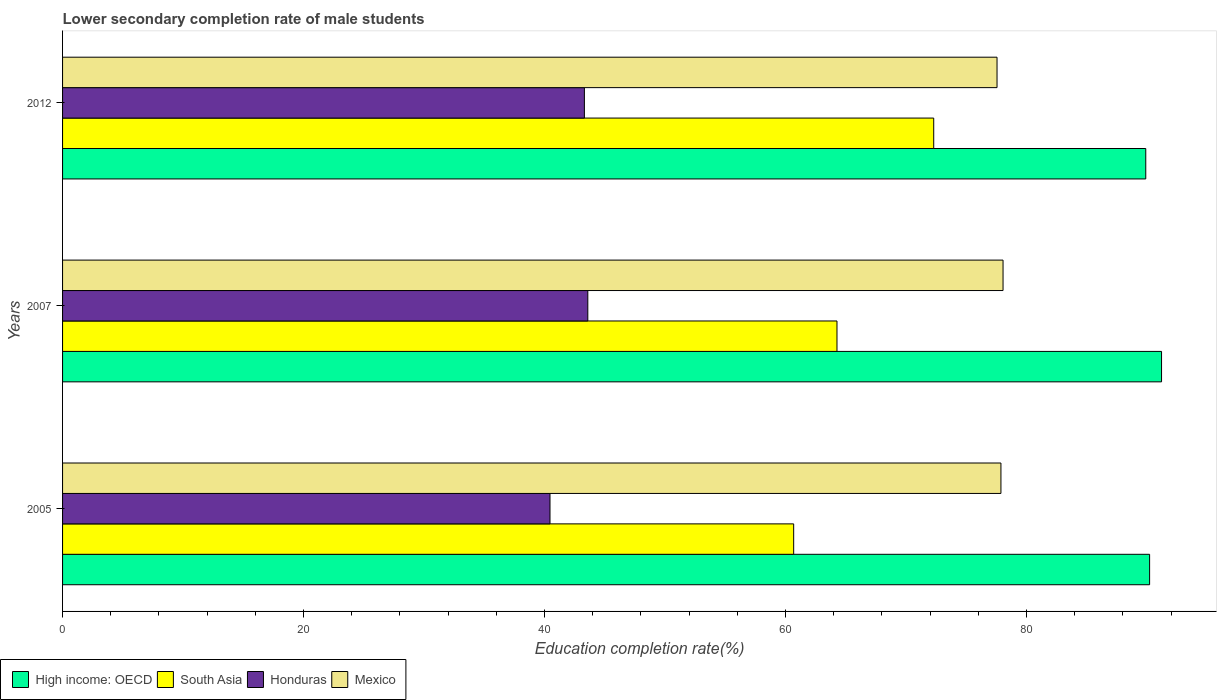How many different coloured bars are there?
Provide a succinct answer. 4. How many groups of bars are there?
Your response must be concise. 3. Are the number of bars per tick equal to the number of legend labels?
Make the answer very short. Yes. Are the number of bars on each tick of the Y-axis equal?
Give a very brief answer. Yes. How many bars are there on the 2nd tick from the bottom?
Provide a succinct answer. 4. What is the label of the 1st group of bars from the top?
Ensure brevity in your answer.  2012. What is the lower secondary completion rate of male students in South Asia in 2012?
Keep it short and to the point. 72.3. Across all years, what is the maximum lower secondary completion rate of male students in High income: OECD?
Keep it short and to the point. 91.2. Across all years, what is the minimum lower secondary completion rate of male students in Honduras?
Provide a succinct answer. 40.45. In which year was the lower secondary completion rate of male students in Mexico minimum?
Ensure brevity in your answer.  2012. What is the total lower secondary completion rate of male students in South Asia in the graph?
Your answer should be very brief. 197.23. What is the difference between the lower secondary completion rate of male students in High income: OECD in 2005 and that in 2012?
Your answer should be compact. 0.32. What is the difference between the lower secondary completion rate of male students in Mexico in 2005 and the lower secondary completion rate of male students in High income: OECD in 2007?
Give a very brief answer. -13.33. What is the average lower secondary completion rate of male students in South Asia per year?
Offer a very short reply. 65.74. In the year 2012, what is the difference between the lower secondary completion rate of male students in Honduras and lower secondary completion rate of male students in Mexico?
Provide a short and direct response. -34.24. What is the ratio of the lower secondary completion rate of male students in High income: OECD in 2005 to that in 2007?
Provide a succinct answer. 0.99. Is the lower secondary completion rate of male students in Mexico in 2005 less than that in 2012?
Your response must be concise. No. What is the difference between the highest and the second highest lower secondary completion rate of male students in South Asia?
Make the answer very short. 8.03. What is the difference between the highest and the lowest lower secondary completion rate of male students in South Asia?
Ensure brevity in your answer.  11.62. In how many years, is the lower secondary completion rate of male students in High income: OECD greater than the average lower secondary completion rate of male students in High income: OECD taken over all years?
Your answer should be very brief. 1. Is the sum of the lower secondary completion rate of male students in Honduras in 2005 and 2007 greater than the maximum lower secondary completion rate of male students in South Asia across all years?
Provide a succinct answer. Yes. Is it the case that in every year, the sum of the lower secondary completion rate of male students in Honduras and lower secondary completion rate of male students in High income: OECD is greater than the sum of lower secondary completion rate of male students in Mexico and lower secondary completion rate of male students in South Asia?
Ensure brevity in your answer.  No. What does the 3rd bar from the top in 2005 represents?
Your answer should be compact. South Asia. What does the 1st bar from the bottom in 2007 represents?
Ensure brevity in your answer.  High income: OECD. Is it the case that in every year, the sum of the lower secondary completion rate of male students in High income: OECD and lower secondary completion rate of male students in South Asia is greater than the lower secondary completion rate of male students in Honduras?
Give a very brief answer. Yes. How many bars are there?
Offer a very short reply. 12. Does the graph contain any zero values?
Provide a short and direct response. No. How many legend labels are there?
Make the answer very short. 4. What is the title of the graph?
Ensure brevity in your answer.  Lower secondary completion rate of male students. Does "Kosovo" appear as one of the legend labels in the graph?
Your response must be concise. No. What is the label or title of the X-axis?
Make the answer very short. Education completion rate(%). What is the Education completion rate(%) of High income: OECD in 2005?
Your answer should be compact. 90.21. What is the Education completion rate(%) of South Asia in 2005?
Your answer should be very brief. 60.67. What is the Education completion rate(%) in Honduras in 2005?
Your answer should be very brief. 40.45. What is the Education completion rate(%) in Mexico in 2005?
Offer a very short reply. 77.87. What is the Education completion rate(%) in High income: OECD in 2007?
Provide a succinct answer. 91.2. What is the Education completion rate(%) of South Asia in 2007?
Your response must be concise. 64.27. What is the Education completion rate(%) in Honduras in 2007?
Offer a terse response. 43.59. What is the Education completion rate(%) of Mexico in 2007?
Your answer should be very brief. 78.05. What is the Education completion rate(%) in High income: OECD in 2012?
Your answer should be compact. 89.89. What is the Education completion rate(%) of South Asia in 2012?
Ensure brevity in your answer.  72.3. What is the Education completion rate(%) in Honduras in 2012?
Your answer should be compact. 43.3. What is the Education completion rate(%) of Mexico in 2012?
Offer a very short reply. 77.55. Across all years, what is the maximum Education completion rate(%) in High income: OECD?
Offer a terse response. 91.2. Across all years, what is the maximum Education completion rate(%) in South Asia?
Offer a very short reply. 72.3. Across all years, what is the maximum Education completion rate(%) in Honduras?
Your response must be concise. 43.59. Across all years, what is the maximum Education completion rate(%) of Mexico?
Your answer should be compact. 78.05. Across all years, what is the minimum Education completion rate(%) in High income: OECD?
Offer a very short reply. 89.89. Across all years, what is the minimum Education completion rate(%) of South Asia?
Your response must be concise. 60.67. Across all years, what is the minimum Education completion rate(%) of Honduras?
Give a very brief answer. 40.45. Across all years, what is the minimum Education completion rate(%) of Mexico?
Ensure brevity in your answer.  77.55. What is the total Education completion rate(%) in High income: OECD in the graph?
Your response must be concise. 271.3. What is the total Education completion rate(%) in South Asia in the graph?
Provide a succinct answer. 197.23. What is the total Education completion rate(%) of Honduras in the graph?
Provide a succinct answer. 127.34. What is the total Education completion rate(%) of Mexico in the graph?
Keep it short and to the point. 233.47. What is the difference between the Education completion rate(%) of High income: OECD in 2005 and that in 2007?
Keep it short and to the point. -0.99. What is the difference between the Education completion rate(%) in South Asia in 2005 and that in 2007?
Provide a succinct answer. -3.6. What is the difference between the Education completion rate(%) of Honduras in 2005 and that in 2007?
Your answer should be compact. -3.14. What is the difference between the Education completion rate(%) in Mexico in 2005 and that in 2007?
Your answer should be compact. -0.17. What is the difference between the Education completion rate(%) in High income: OECD in 2005 and that in 2012?
Ensure brevity in your answer.  0.32. What is the difference between the Education completion rate(%) in South Asia in 2005 and that in 2012?
Offer a terse response. -11.62. What is the difference between the Education completion rate(%) of Honduras in 2005 and that in 2012?
Make the answer very short. -2.85. What is the difference between the Education completion rate(%) of Mexico in 2005 and that in 2012?
Your response must be concise. 0.32. What is the difference between the Education completion rate(%) of High income: OECD in 2007 and that in 2012?
Your answer should be very brief. 1.31. What is the difference between the Education completion rate(%) in South Asia in 2007 and that in 2012?
Your answer should be very brief. -8.03. What is the difference between the Education completion rate(%) of Honduras in 2007 and that in 2012?
Offer a terse response. 0.28. What is the difference between the Education completion rate(%) in Mexico in 2007 and that in 2012?
Ensure brevity in your answer.  0.5. What is the difference between the Education completion rate(%) in High income: OECD in 2005 and the Education completion rate(%) in South Asia in 2007?
Ensure brevity in your answer.  25.94. What is the difference between the Education completion rate(%) of High income: OECD in 2005 and the Education completion rate(%) of Honduras in 2007?
Keep it short and to the point. 46.62. What is the difference between the Education completion rate(%) of High income: OECD in 2005 and the Education completion rate(%) of Mexico in 2007?
Provide a short and direct response. 12.16. What is the difference between the Education completion rate(%) in South Asia in 2005 and the Education completion rate(%) in Honduras in 2007?
Your answer should be very brief. 17.08. What is the difference between the Education completion rate(%) of South Asia in 2005 and the Education completion rate(%) of Mexico in 2007?
Keep it short and to the point. -17.38. What is the difference between the Education completion rate(%) in Honduras in 2005 and the Education completion rate(%) in Mexico in 2007?
Your response must be concise. -37.6. What is the difference between the Education completion rate(%) of High income: OECD in 2005 and the Education completion rate(%) of South Asia in 2012?
Provide a short and direct response. 17.92. What is the difference between the Education completion rate(%) in High income: OECD in 2005 and the Education completion rate(%) in Honduras in 2012?
Ensure brevity in your answer.  46.91. What is the difference between the Education completion rate(%) in High income: OECD in 2005 and the Education completion rate(%) in Mexico in 2012?
Make the answer very short. 12.66. What is the difference between the Education completion rate(%) in South Asia in 2005 and the Education completion rate(%) in Honduras in 2012?
Offer a terse response. 17.37. What is the difference between the Education completion rate(%) in South Asia in 2005 and the Education completion rate(%) in Mexico in 2012?
Provide a short and direct response. -16.88. What is the difference between the Education completion rate(%) in Honduras in 2005 and the Education completion rate(%) in Mexico in 2012?
Make the answer very short. -37.1. What is the difference between the Education completion rate(%) of High income: OECD in 2007 and the Education completion rate(%) of South Asia in 2012?
Keep it short and to the point. 18.91. What is the difference between the Education completion rate(%) of High income: OECD in 2007 and the Education completion rate(%) of Honduras in 2012?
Keep it short and to the point. 47.9. What is the difference between the Education completion rate(%) in High income: OECD in 2007 and the Education completion rate(%) in Mexico in 2012?
Keep it short and to the point. 13.65. What is the difference between the Education completion rate(%) in South Asia in 2007 and the Education completion rate(%) in Honduras in 2012?
Ensure brevity in your answer.  20.96. What is the difference between the Education completion rate(%) of South Asia in 2007 and the Education completion rate(%) of Mexico in 2012?
Provide a short and direct response. -13.28. What is the difference between the Education completion rate(%) of Honduras in 2007 and the Education completion rate(%) of Mexico in 2012?
Offer a terse response. -33.96. What is the average Education completion rate(%) of High income: OECD per year?
Offer a very short reply. 90.43. What is the average Education completion rate(%) in South Asia per year?
Your answer should be compact. 65.75. What is the average Education completion rate(%) in Honduras per year?
Your answer should be very brief. 42.45. What is the average Education completion rate(%) of Mexico per year?
Make the answer very short. 77.82. In the year 2005, what is the difference between the Education completion rate(%) in High income: OECD and Education completion rate(%) in South Asia?
Keep it short and to the point. 29.54. In the year 2005, what is the difference between the Education completion rate(%) in High income: OECD and Education completion rate(%) in Honduras?
Make the answer very short. 49.76. In the year 2005, what is the difference between the Education completion rate(%) of High income: OECD and Education completion rate(%) of Mexico?
Give a very brief answer. 12.34. In the year 2005, what is the difference between the Education completion rate(%) in South Asia and Education completion rate(%) in Honduras?
Provide a succinct answer. 20.22. In the year 2005, what is the difference between the Education completion rate(%) in South Asia and Education completion rate(%) in Mexico?
Your answer should be very brief. -17.2. In the year 2005, what is the difference between the Education completion rate(%) in Honduras and Education completion rate(%) in Mexico?
Make the answer very short. -37.42. In the year 2007, what is the difference between the Education completion rate(%) in High income: OECD and Education completion rate(%) in South Asia?
Your answer should be compact. 26.93. In the year 2007, what is the difference between the Education completion rate(%) of High income: OECD and Education completion rate(%) of Honduras?
Your answer should be very brief. 47.61. In the year 2007, what is the difference between the Education completion rate(%) in High income: OECD and Education completion rate(%) in Mexico?
Your response must be concise. 13.15. In the year 2007, what is the difference between the Education completion rate(%) in South Asia and Education completion rate(%) in Honduras?
Keep it short and to the point. 20.68. In the year 2007, what is the difference between the Education completion rate(%) in South Asia and Education completion rate(%) in Mexico?
Provide a short and direct response. -13.78. In the year 2007, what is the difference between the Education completion rate(%) in Honduras and Education completion rate(%) in Mexico?
Your answer should be very brief. -34.46. In the year 2012, what is the difference between the Education completion rate(%) of High income: OECD and Education completion rate(%) of South Asia?
Give a very brief answer. 17.6. In the year 2012, what is the difference between the Education completion rate(%) of High income: OECD and Education completion rate(%) of Honduras?
Your answer should be compact. 46.59. In the year 2012, what is the difference between the Education completion rate(%) in High income: OECD and Education completion rate(%) in Mexico?
Your answer should be compact. 12.34. In the year 2012, what is the difference between the Education completion rate(%) of South Asia and Education completion rate(%) of Honduras?
Your response must be concise. 28.99. In the year 2012, what is the difference between the Education completion rate(%) of South Asia and Education completion rate(%) of Mexico?
Your answer should be compact. -5.25. In the year 2012, what is the difference between the Education completion rate(%) of Honduras and Education completion rate(%) of Mexico?
Provide a short and direct response. -34.24. What is the ratio of the Education completion rate(%) in South Asia in 2005 to that in 2007?
Provide a short and direct response. 0.94. What is the ratio of the Education completion rate(%) in Honduras in 2005 to that in 2007?
Offer a very short reply. 0.93. What is the ratio of the Education completion rate(%) in High income: OECD in 2005 to that in 2012?
Ensure brevity in your answer.  1. What is the ratio of the Education completion rate(%) in South Asia in 2005 to that in 2012?
Provide a succinct answer. 0.84. What is the ratio of the Education completion rate(%) of Honduras in 2005 to that in 2012?
Make the answer very short. 0.93. What is the ratio of the Education completion rate(%) in High income: OECD in 2007 to that in 2012?
Ensure brevity in your answer.  1.01. What is the ratio of the Education completion rate(%) of South Asia in 2007 to that in 2012?
Provide a succinct answer. 0.89. What is the ratio of the Education completion rate(%) in Mexico in 2007 to that in 2012?
Offer a terse response. 1.01. What is the difference between the highest and the second highest Education completion rate(%) of High income: OECD?
Provide a short and direct response. 0.99. What is the difference between the highest and the second highest Education completion rate(%) in South Asia?
Your response must be concise. 8.03. What is the difference between the highest and the second highest Education completion rate(%) of Honduras?
Your answer should be compact. 0.28. What is the difference between the highest and the second highest Education completion rate(%) of Mexico?
Give a very brief answer. 0.17. What is the difference between the highest and the lowest Education completion rate(%) of High income: OECD?
Offer a very short reply. 1.31. What is the difference between the highest and the lowest Education completion rate(%) of South Asia?
Keep it short and to the point. 11.62. What is the difference between the highest and the lowest Education completion rate(%) of Honduras?
Keep it short and to the point. 3.14. What is the difference between the highest and the lowest Education completion rate(%) of Mexico?
Make the answer very short. 0.5. 